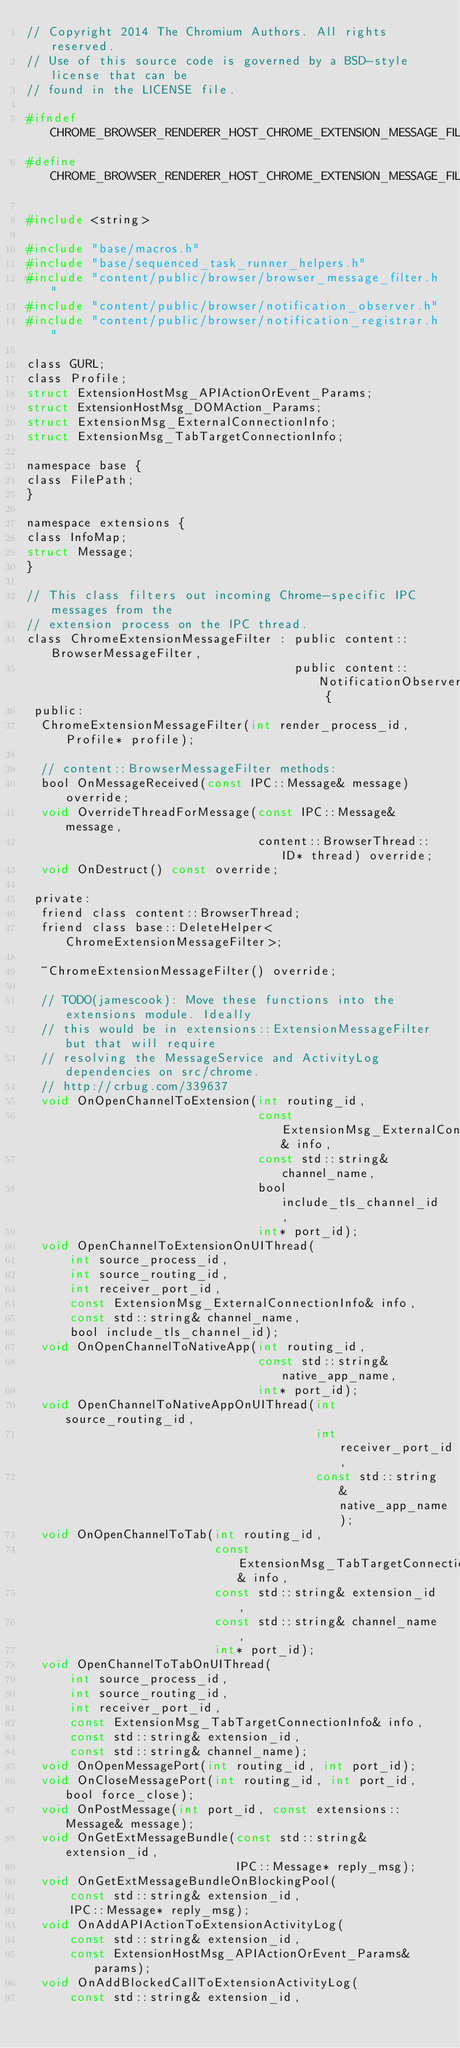<code> <loc_0><loc_0><loc_500><loc_500><_C_>// Copyright 2014 The Chromium Authors. All rights reserved.
// Use of this source code is governed by a BSD-style license that can be
// found in the LICENSE file.

#ifndef CHROME_BROWSER_RENDERER_HOST_CHROME_EXTENSION_MESSAGE_FILTER_H_
#define CHROME_BROWSER_RENDERER_HOST_CHROME_EXTENSION_MESSAGE_FILTER_H_

#include <string>

#include "base/macros.h"
#include "base/sequenced_task_runner_helpers.h"
#include "content/public/browser/browser_message_filter.h"
#include "content/public/browser/notification_observer.h"
#include "content/public/browser/notification_registrar.h"

class GURL;
class Profile;
struct ExtensionHostMsg_APIActionOrEvent_Params;
struct ExtensionHostMsg_DOMAction_Params;
struct ExtensionMsg_ExternalConnectionInfo;
struct ExtensionMsg_TabTargetConnectionInfo;

namespace base {
class FilePath;
}

namespace extensions {
class InfoMap;
struct Message;
}

// This class filters out incoming Chrome-specific IPC messages from the
// extension process on the IPC thread.
class ChromeExtensionMessageFilter : public content::BrowserMessageFilter,
                                     public content::NotificationObserver {
 public:
  ChromeExtensionMessageFilter(int render_process_id, Profile* profile);

  // content::BrowserMessageFilter methods:
  bool OnMessageReceived(const IPC::Message& message) override;
  void OverrideThreadForMessage(const IPC::Message& message,
                                content::BrowserThread::ID* thread) override;
  void OnDestruct() const override;

 private:
  friend class content::BrowserThread;
  friend class base::DeleteHelper<ChromeExtensionMessageFilter>;

  ~ChromeExtensionMessageFilter() override;

  // TODO(jamescook): Move these functions into the extensions module. Ideally
  // this would be in extensions::ExtensionMessageFilter but that will require
  // resolving the MessageService and ActivityLog dependencies on src/chrome.
  // http://crbug.com/339637
  void OnOpenChannelToExtension(int routing_id,
                                const ExtensionMsg_ExternalConnectionInfo& info,
                                const std::string& channel_name,
                                bool include_tls_channel_id,
                                int* port_id);
  void OpenChannelToExtensionOnUIThread(
      int source_process_id,
      int source_routing_id,
      int receiver_port_id,
      const ExtensionMsg_ExternalConnectionInfo& info,
      const std::string& channel_name,
      bool include_tls_channel_id);
  void OnOpenChannelToNativeApp(int routing_id,
                                const std::string& native_app_name,
                                int* port_id);
  void OpenChannelToNativeAppOnUIThread(int source_routing_id,
                                        int receiver_port_id,
                                        const std::string& native_app_name);
  void OnOpenChannelToTab(int routing_id,
                          const ExtensionMsg_TabTargetConnectionInfo& info,
                          const std::string& extension_id,
                          const std::string& channel_name,
                          int* port_id);
  void OpenChannelToTabOnUIThread(
      int source_process_id,
      int source_routing_id,
      int receiver_port_id,
      const ExtensionMsg_TabTargetConnectionInfo& info,
      const std::string& extension_id,
      const std::string& channel_name);
  void OnOpenMessagePort(int routing_id, int port_id);
  void OnCloseMessagePort(int routing_id, int port_id, bool force_close);
  void OnPostMessage(int port_id, const extensions::Message& message);
  void OnGetExtMessageBundle(const std::string& extension_id,
                             IPC::Message* reply_msg);
  void OnGetExtMessageBundleOnBlockingPool(
      const std::string& extension_id,
      IPC::Message* reply_msg);
  void OnAddAPIActionToExtensionActivityLog(
      const std::string& extension_id,
      const ExtensionHostMsg_APIActionOrEvent_Params& params);
  void OnAddBlockedCallToExtensionActivityLog(
      const std::string& extension_id,</code> 